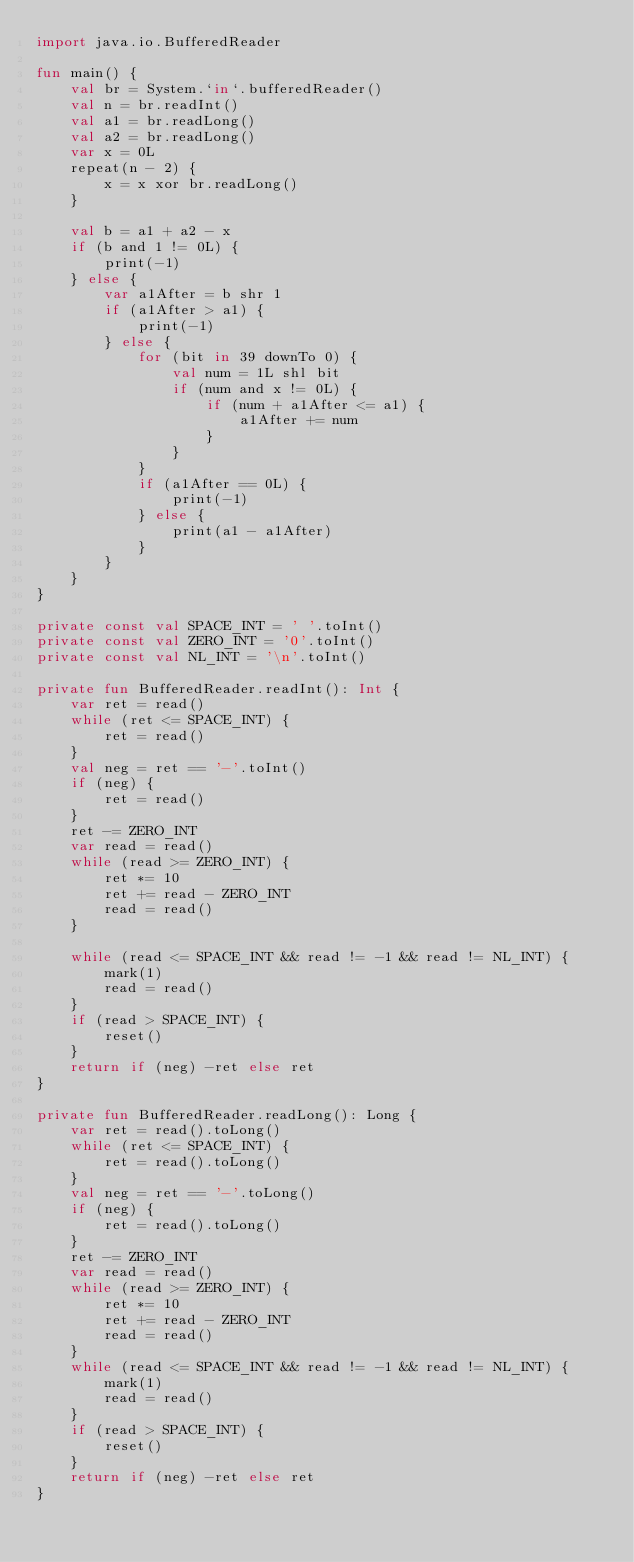<code> <loc_0><loc_0><loc_500><loc_500><_Kotlin_>import java.io.BufferedReader

fun main() {
    val br = System.`in`.bufferedReader()
    val n = br.readInt()
    val a1 = br.readLong()
    val a2 = br.readLong()
    var x = 0L
    repeat(n - 2) {
        x = x xor br.readLong()
    }

    val b = a1 + a2 - x
    if (b and 1 != 0L) {
        print(-1)
    } else {
        var a1After = b shr 1
        if (a1After > a1) {
            print(-1)
        } else {
            for (bit in 39 downTo 0) {
                val num = 1L shl bit
                if (num and x != 0L) {
                    if (num + a1After <= a1) {
                        a1After += num
                    }
                }
            }
            if (a1After == 0L) {
                print(-1)
            } else {
                print(a1 - a1After)
            }
        }
    }
}

private const val SPACE_INT = ' '.toInt()
private const val ZERO_INT = '0'.toInt()
private const val NL_INT = '\n'.toInt()

private fun BufferedReader.readInt(): Int {
    var ret = read()
    while (ret <= SPACE_INT) {
        ret = read()
    }
    val neg = ret == '-'.toInt()
    if (neg) {
        ret = read()
    }
    ret -= ZERO_INT
    var read = read()
    while (read >= ZERO_INT) {
        ret *= 10
        ret += read - ZERO_INT
        read = read()
    }

    while (read <= SPACE_INT && read != -1 && read != NL_INT) {
        mark(1)
        read = read()
    }
    if (read > SPACE_INT) {
        reset()
    }
    return if (neg) -ret else ret
}

private fun BufferedReader.readLong(): Long {
    var ret = read().toLong()
    while (ret <= SPACE_INT) {
        ret = read().toLong()
    }
    val neg = ret == '-'.toLong()
    if (neg) {
        ret = read().toLong()
    }
    ret -= ZERO_INT
    var read = read()
    while (read >= ZERO_INT) {
        ret *= 10
        ret += read - ZERO_INT
        read = read()
    }
    while (read <= SPACE_INT && read != -1 && read != NL_INT) {
        mark(1)
        read = read()
    }
    if (read > SPACE_INT) {
        reset()
    }
    return if (neg) -ret else ret
}</code> 